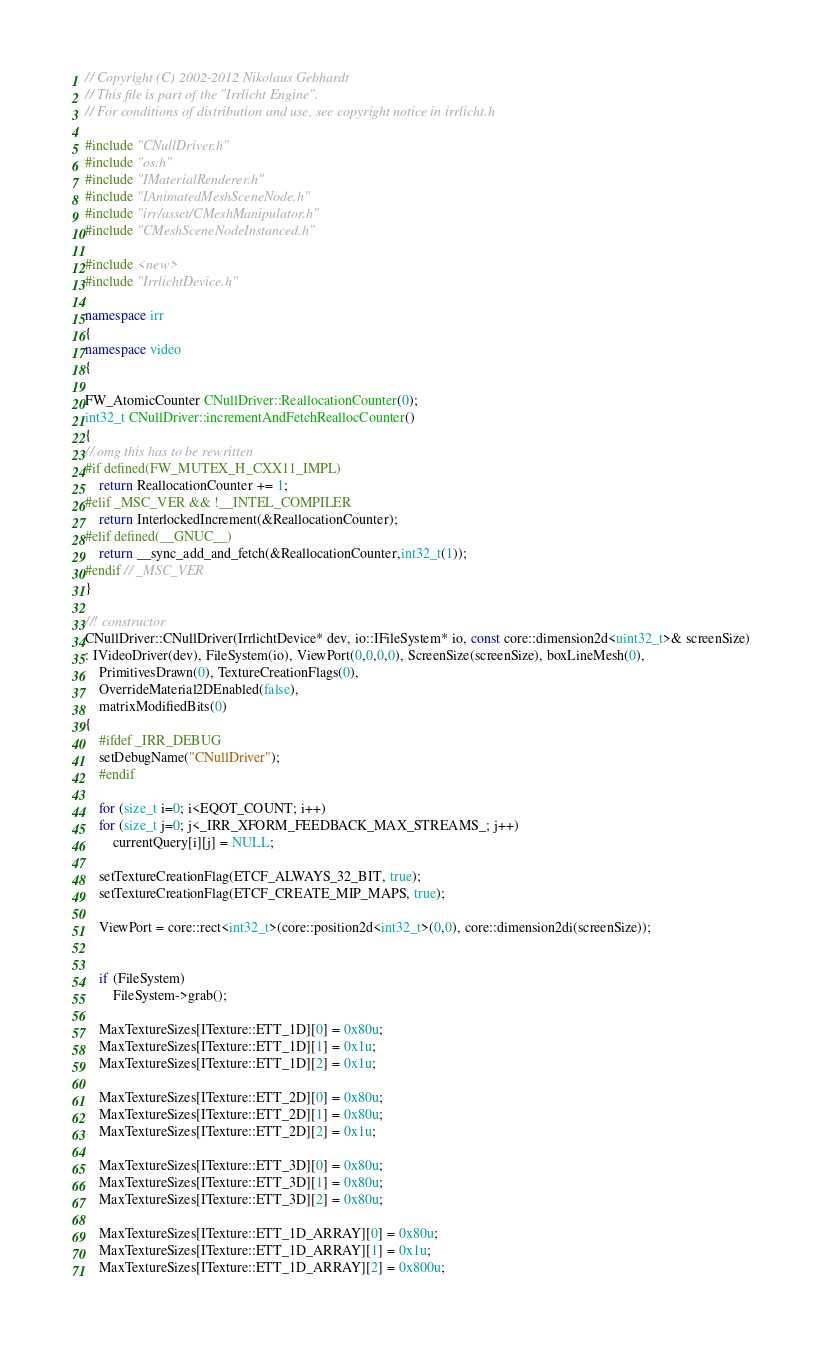Convert code to text. <code><loc_0><loc_0><loc_500><loc_500><_C++_>// Copyright (C) 2002-2012 Nikolaus Gebhardt
// This file is part of the "Irrlicht Engine".
// For conditions of distribution and use, see copyright notice in irrlicht.h

#include "CNullDriver.h"
#include "os.h"
#include "IMaterialRenderer.h"
#include "IAnimatedMeshSceneNode.h"
#include "irr/asset/CMeshManipulator.h"
#include "CMeshSceneNodeInstanced.h"

#include <new>
#include "IrrlichtDevice.h"

namespace irr
{
namespace video
{

FW_AtomicCounter CNullDriver::ReallocationCounter(0);
int32_t CNullDriver::incrementAndFetchReallocCounter()
{
// omg this has to be rewritten
#if defined(FW_MUTEX_H_CXX11_IMPL)
	return ReallocationCounter += 1;
#elif _MSC_VER && !__INTEL_COMPILER
    return InterlockedIncrement(&ReallocationCounter);
#elif defined(__GNUC__)
    return __sync_add_and_fetch(&ReallocationCounter,int32_t(1));
#endif // _MSC_VER
}

//! constructor
CNullDriver::CNullDriver(IrrlichtDevice* dev, io::IFileSystem* io, const core::dimension2d<uint32_t>& screenSize)
: IVideoDriver(dev), FileSystem(io), ViewPort(0,0,0,0), ScreenSize(screenSize), boxLineMesh(0),
	PrimitivesDrawn(0), TextureCreationFlags(0),
	OverrideMaterial2DEnabled(false),
	matrixModifiedBits(0)
{
	#ifdef _IRR_DEBUG
	setDebugName("CNullDriver");
	#endif

	for (size_t i=0; i<EQOT_COUNT; i++)
    for (size_t j=0; j<_IRR_XFORM_FEEDBACK_MAX_STREAMS_; j++)
        currentQuery[i][j] = NULL;

	setTextureCreationFlag(ETCF_ALWAYS_32_BIT, true);
	setTextureCreationFlag(ETCF_CREATE_MIP_MAPS, true);

	ViewPort = core::rect<int32_t>(core::position2d<int32_t>(0,0), core::dimension2di(screenSize));


	if (FileSystem)
		FileSystem->grab();

    MaxTextureSizes[ITexture::ETT_1D][0] = 0x80u;
    MaxTextureSizes[ITexture::ETT_1D][1] = 0x1u;
    MaxTextureSizes[ITexture::ETT_1D][2] = 0x1u;

    MaxTextureSizes[ITexture::ETT_2D][0] = 0x80u;
    MaxTextureSizes[ITexture::ETT_2D][1] = 0x80u;
    MaxTextureSizes[ITexture::ETT_2D][2] = 0x1u;

    MaxTextureSizes[ITexture::ETT_3D][0] = 0x80u;
    MaxTextureSizes[ITexture::ETT_3D][1] = 0x80u;
    MaxTextureSizes[ITexture::ETT_3D][2] = 0x80u;

    MaxTextureSizes[ITexture::ETT_1D_ARRAY][0] = 0x80u;
    MaxTextureSizes[ITexture::ETT_1D_ARRAY][1] = 0x1u;
    MaxTextureSizes[ITexture::ETT_1D_ARRAY][2] = 0x800u;
</code> 